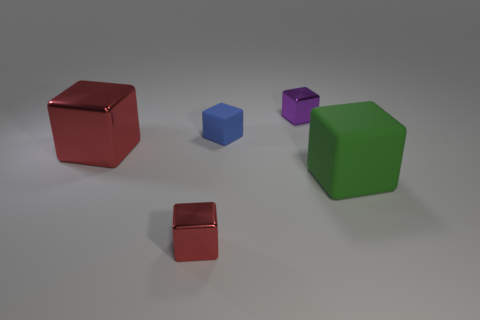There is a green thing that is the same material as the small blue thing; what is its size?
Provide a short and direct response. Large. Is the number of blue blocks less than the number of brown things?
Offer a very short reply. No. How many small things are matte objects or metallic things?
Offer a very short reply. 3. How many small objects are both behind the tiny rubber object and to the left of the blue cube?
Offer a very short reply. 0. Are there more red shiny cubes than large purple cubes?
Ensure brevity in your answer.  Yes. What number of other things are the same shape as the big shiny object?
Keep it short and to the point. 4. What is the material of the cube that is both to the right of the blue rubber cube and in front of the large red cube?
Keep it short and to the point. Rubber. The purple metallic cube is what size?
Provide a succinct answer. Small. What number of blue objects are behind the small shiny thing that is to the left of the small shiny thing that is behind the large red cube?
Keep it short and to the point. 1. The large object right of the metal thing that is in front of the large red block is what shape?
Offer a very short reply. Cube. 